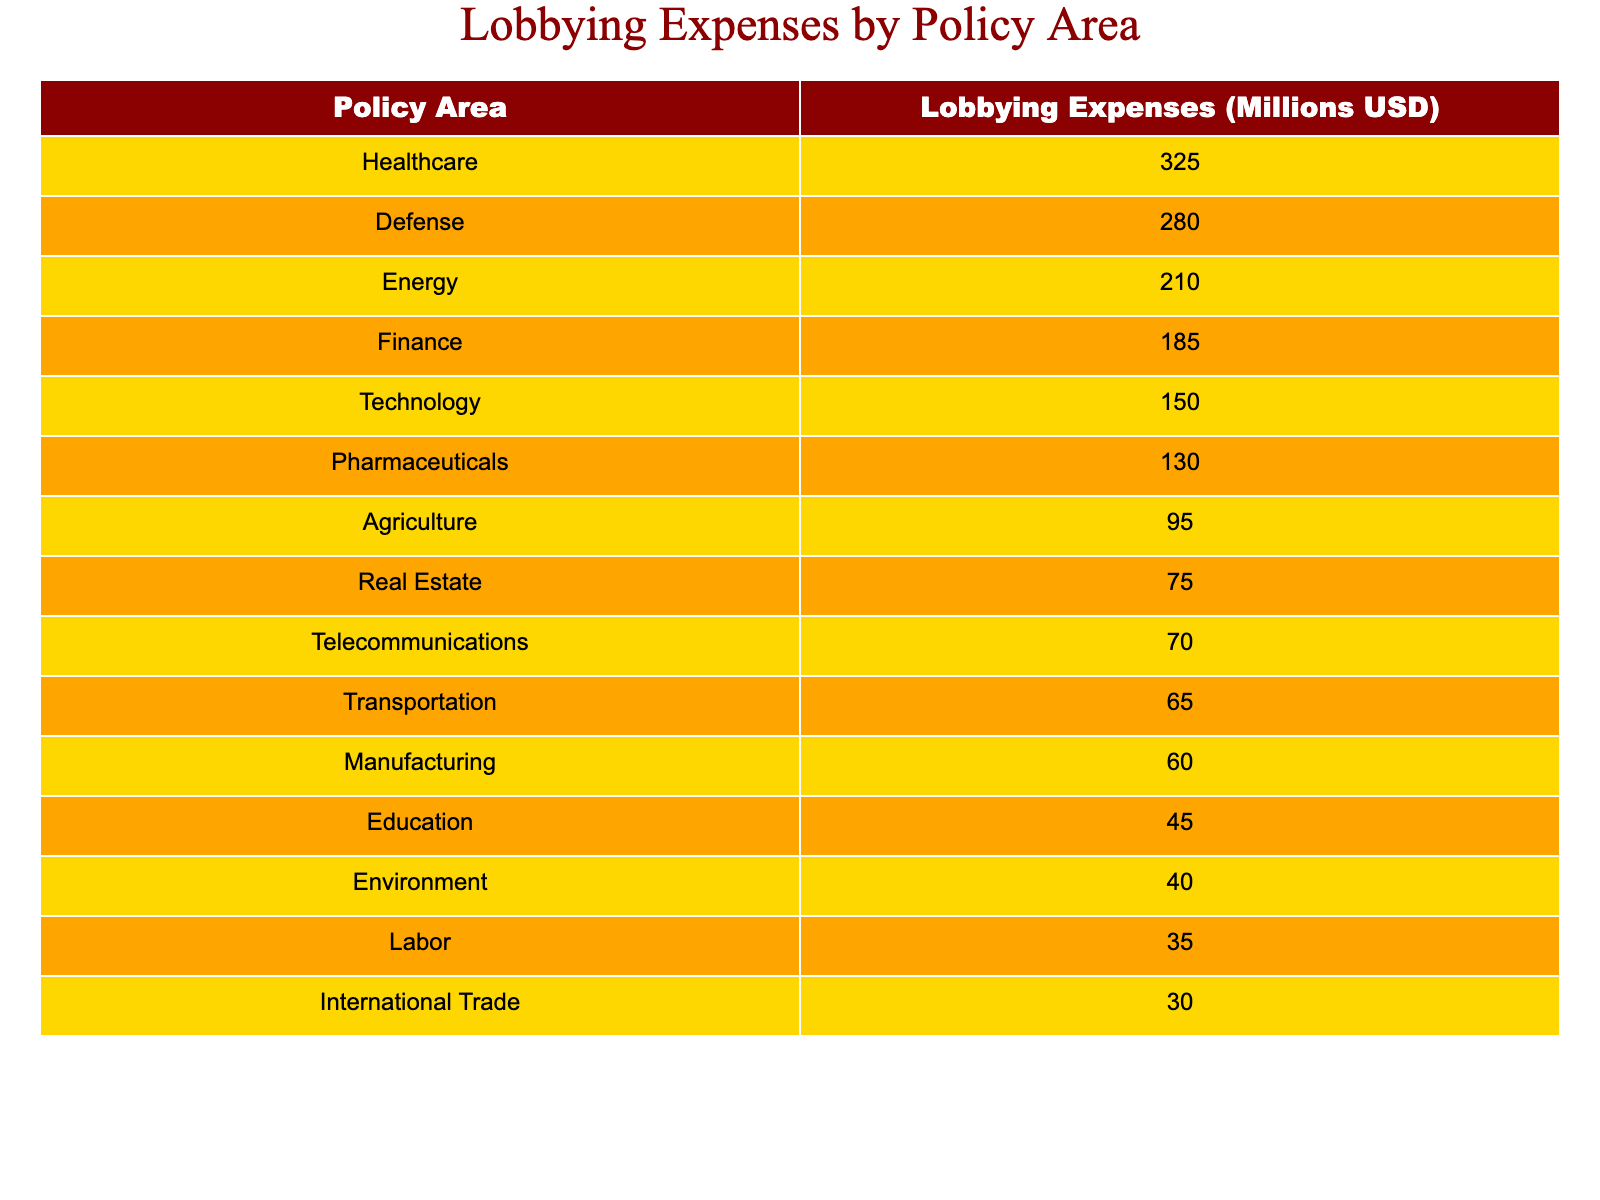What is the highest lobbying expense in the table? The table lists several policy areas with corresponding lobbying expenses. By scanning through the "Lobbying Expenses" column, we can see that "Healthcare" has the highest value at 325 million USD.
Answer: 325 million USD Which policy area has the lowest lobbying expenses? In the "Lobbying Expenses" column, the smallest value is associated with "International Trade," which has 30 million USD.
Answer: 30 million USD What is the total lobbying expense for Healthcare and Pharmaceuticals combined? To find the total, we add the lobbying expenses for "Healthcare" (325 million USD) and "Pharmaceuticals" (130 million USD). The sum is 325 + 130 = 455 million USD.
Answer: 455 million USD Is the lobbying expense for Defense greater than that for Energy? Looking at the expenses, "Defense" is at 280 million USD and "Energy" is at 210 million USD. Since 280 is greater than 210, the statement is true.
Answer: Yes What is the average lobbying expense for the top three policy areas? The top three spending policy areas are "Healthcare" (325 million USD), "Defense" (280 million USD), and "Energy" (210 million USD). To find the average, we sum those (325 + 280 + 210 = 815 million USD) and divide by 3, giving us 815 / 3 = approximately 271.67 million USD.
Answer: 271.67 million USD How much is spent on Agriculture compared to Telecommunications? The expense for "Agriculture" is 95 million USD, and for "Telecommunications," it is 70 million USD. Comparatively, Agriculture spends 25 million USD more than Telecommunications (95 - 70 = 25 million USD).
Answer: 25 million USD Are the total lobbying expenses for Technology and Manufacturing less than 300 million USD? "Technology" has 150 million USD and "Manufacturing" has 60 million USD. To find the total, we add these values (150 + 60 = 210 million USD). Since 210 million USD is less than 300 million USD, the answer is yes.
Answer: Yes What percentage of the total lobbying expenses does the Education policy area represent? First, we find the total of all lobbying expenses, which is 2,265 million USD (325 + 280 + 210 + 185 + 150 + 130 + 95 + 75 + 70 + 65 + 60 + 45 + 40 + 35 + 30). The expense for "Education" is 45 million USD. To find the percentage, we calculate (45 / 2265) * 100, which is approximately 1.98%.
Answer: 1.98% 